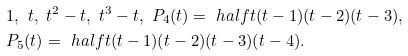<formula> <loc_0><loc_0><loc_500><loc_500>& 1 , \ t , \ t ^ { 2 } - t , \ t ^ { 3 } - t , \ P _ { 4 } ( t ) = \ h a l f t ( t - 1 ) ( t - 2 ) ( t - 3 ) , \\ & P _ { 5 } ( t ) = \ h a l f t ( t - 1 ) ( t - 2 ) ( t - 3 ) ( t - 4 ) .</formula> 